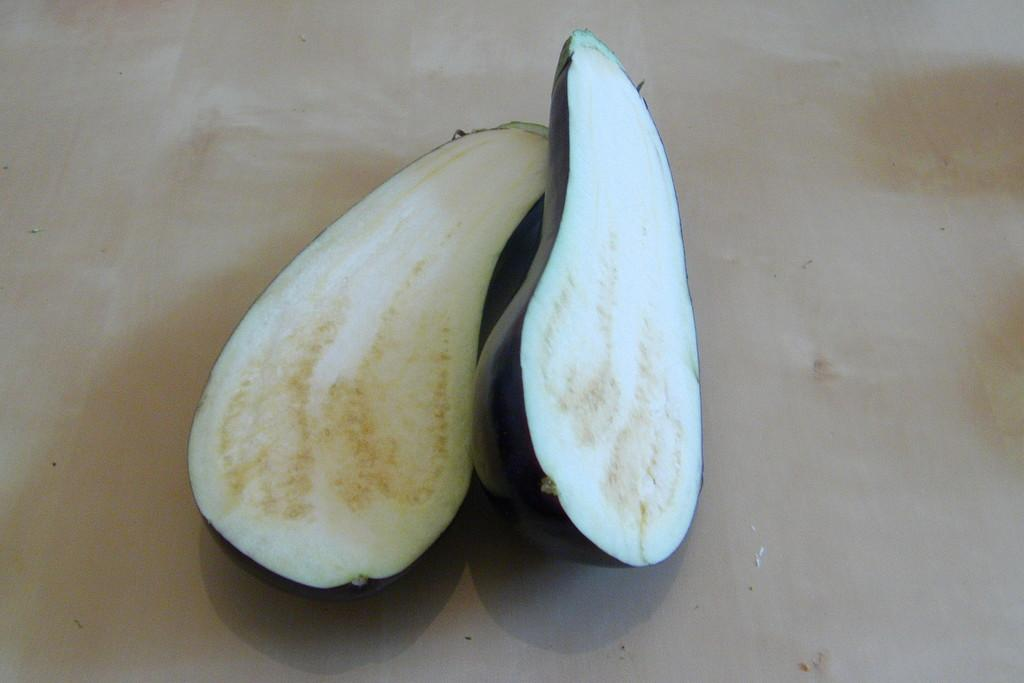What is present on the table in the image? There are brinjal slices in the image. Can you describe the arrangement of the brinjal slices? The brinjal slices are placed on a table. What type of crown is placed on the yard in the image? There is no crown or yard present in the image; it features brinjal slices placed on a table. 